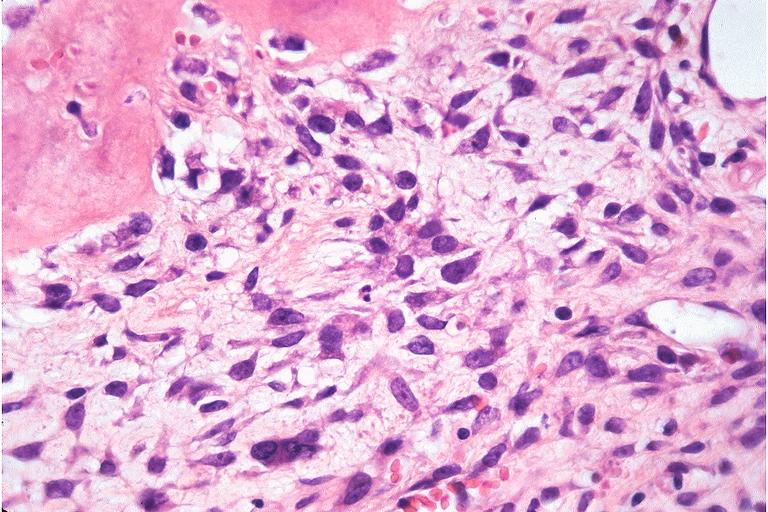where is this?
Answer the question using a single word or phrase. Oral 